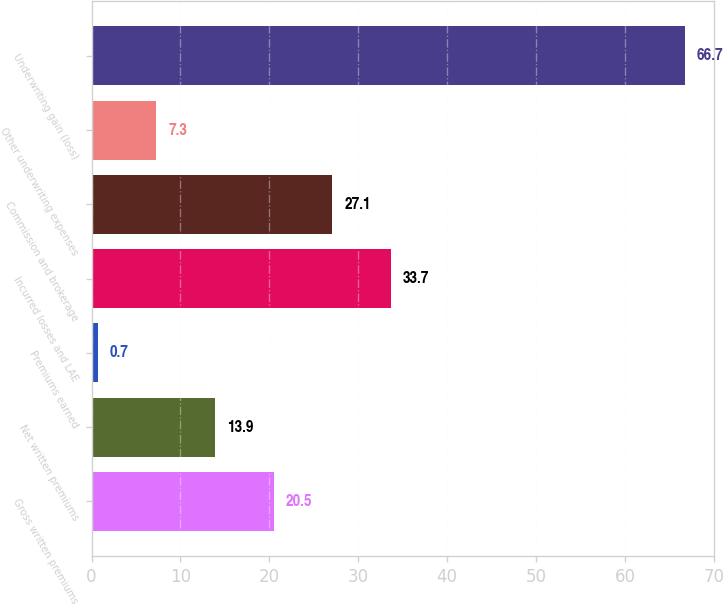<chart> <loc_0><loc_0><loc_500><loc_500><bar_chart><fcel>Gross written premiums<fcel>Net written premiums<fcel>Premiums earned<fcel>Incurred losses and LAE<fcel>Commission and brokerage<fcel>Other underwriting expenses<fcel>Underwriting gain (loss)<nl><fcel>20.5<fcel>13.9<fcel>0.7<fcel>33.7<fcel>27.1<fcel>7.3<fcel>66.7<nl></chart> 